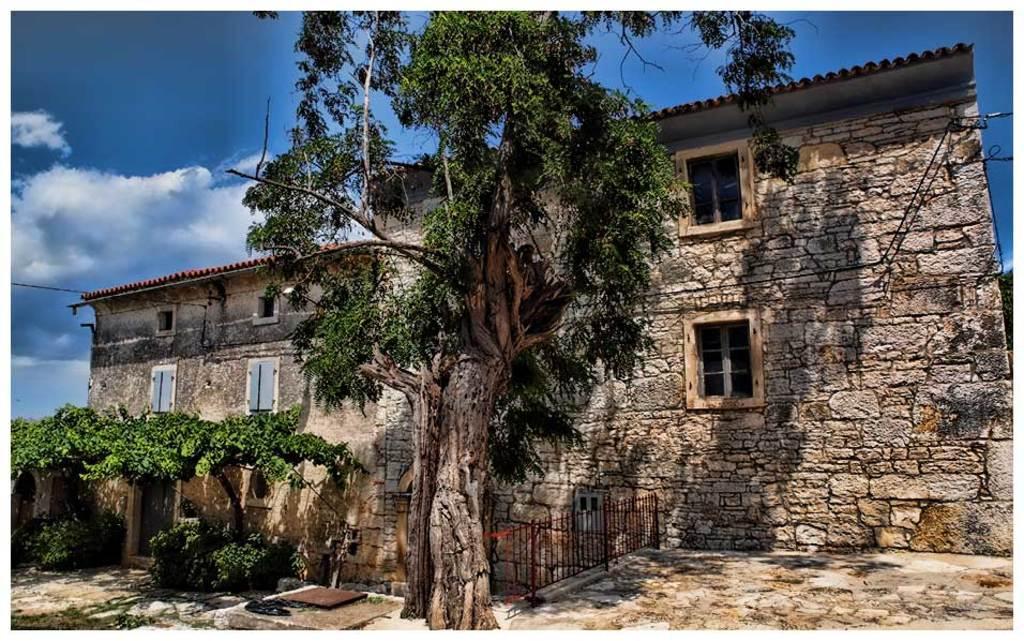How would you summarize this image in a sentence or two? In this image we can see a house with windows. There are plants. There is a tree. In the background of the image there is sky and clouds. 